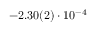<formula> <loc_0><loc_0><loc_500><loc_500>- 2 . 3 0 ( 2 ) \cdot 1 0 ^ { - 4 }</formula> 